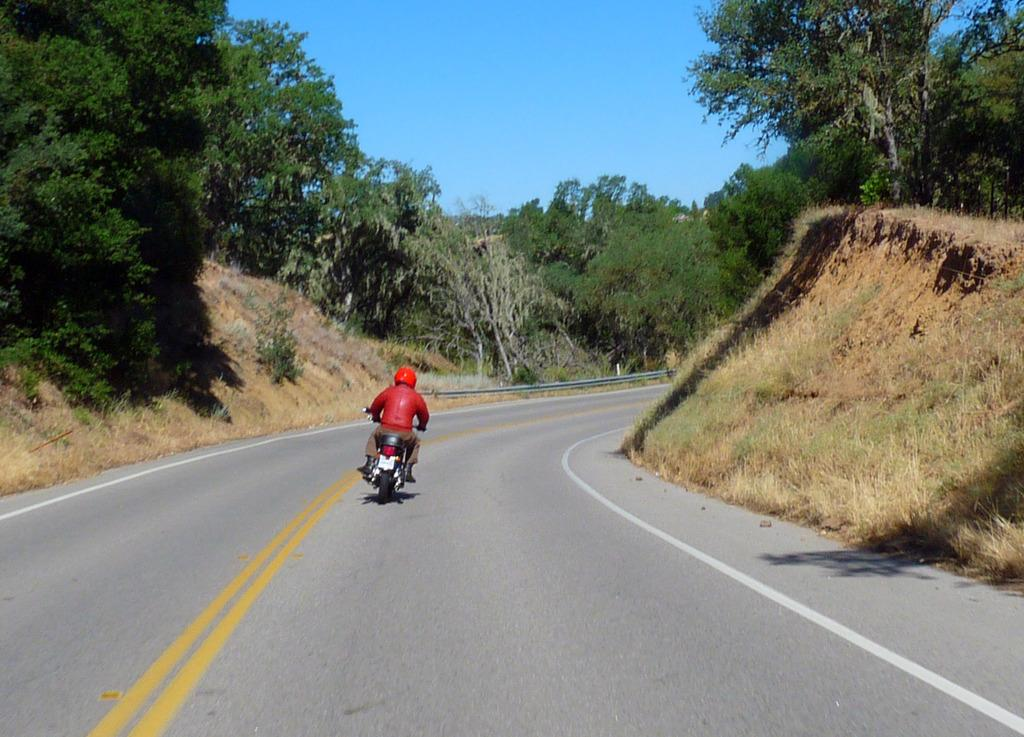What is the person in the image doing? The person is riding a bike in the image. Where is the bike located? The bike is on a road in the image. What can be seen in the background of the image? There are trees, grass, and the sky visible in the background of the image. What type of hospital is visible in the background of the image? There is no hospital present in the image; it features a person riding a bike on a road with trees, grass, and the sky visible in the background. 